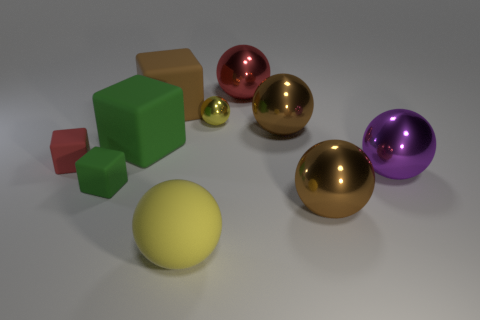Are there any other things that have the same color as the small metal object?
Your response must be concise. Yes. Is the number of tiny green objects behind the tiny yellow metal object the same as the number of large green matte objects in front of the purple metal thing?
Give a very brief answer. Yes. Is the number of brown objects that are right of the large red shiny thing greater than the number of small red rubber things?
Your response must be concise. Yes. How many things are either green rubber objects that are behind the small red cube or brown metal balls?
Make the answer very short. 3. How many big cubes have the same material as the tiny red object?
Your answer should be very brief. 2. There is a large rubber object that is the same color as the tiny ball; what is its shape?
Offer a very short reply. Sphere. Are there any brown things of the same shape as the yellow shiny object?
Give a very brief answer. Yes. There is a yellow thing that is the same size as the purple object; what is its shape?
Provide a short and direct response. Sphere. Is the color of the matte ball the same as the big rubber thing that is to the left of the big brown rubber object?
Keep it short and to the point. No. There is a yellow sphere to the left of the tiny yellow ball; how many matte blocks are in front of it?
Offer a terse response. 0. 